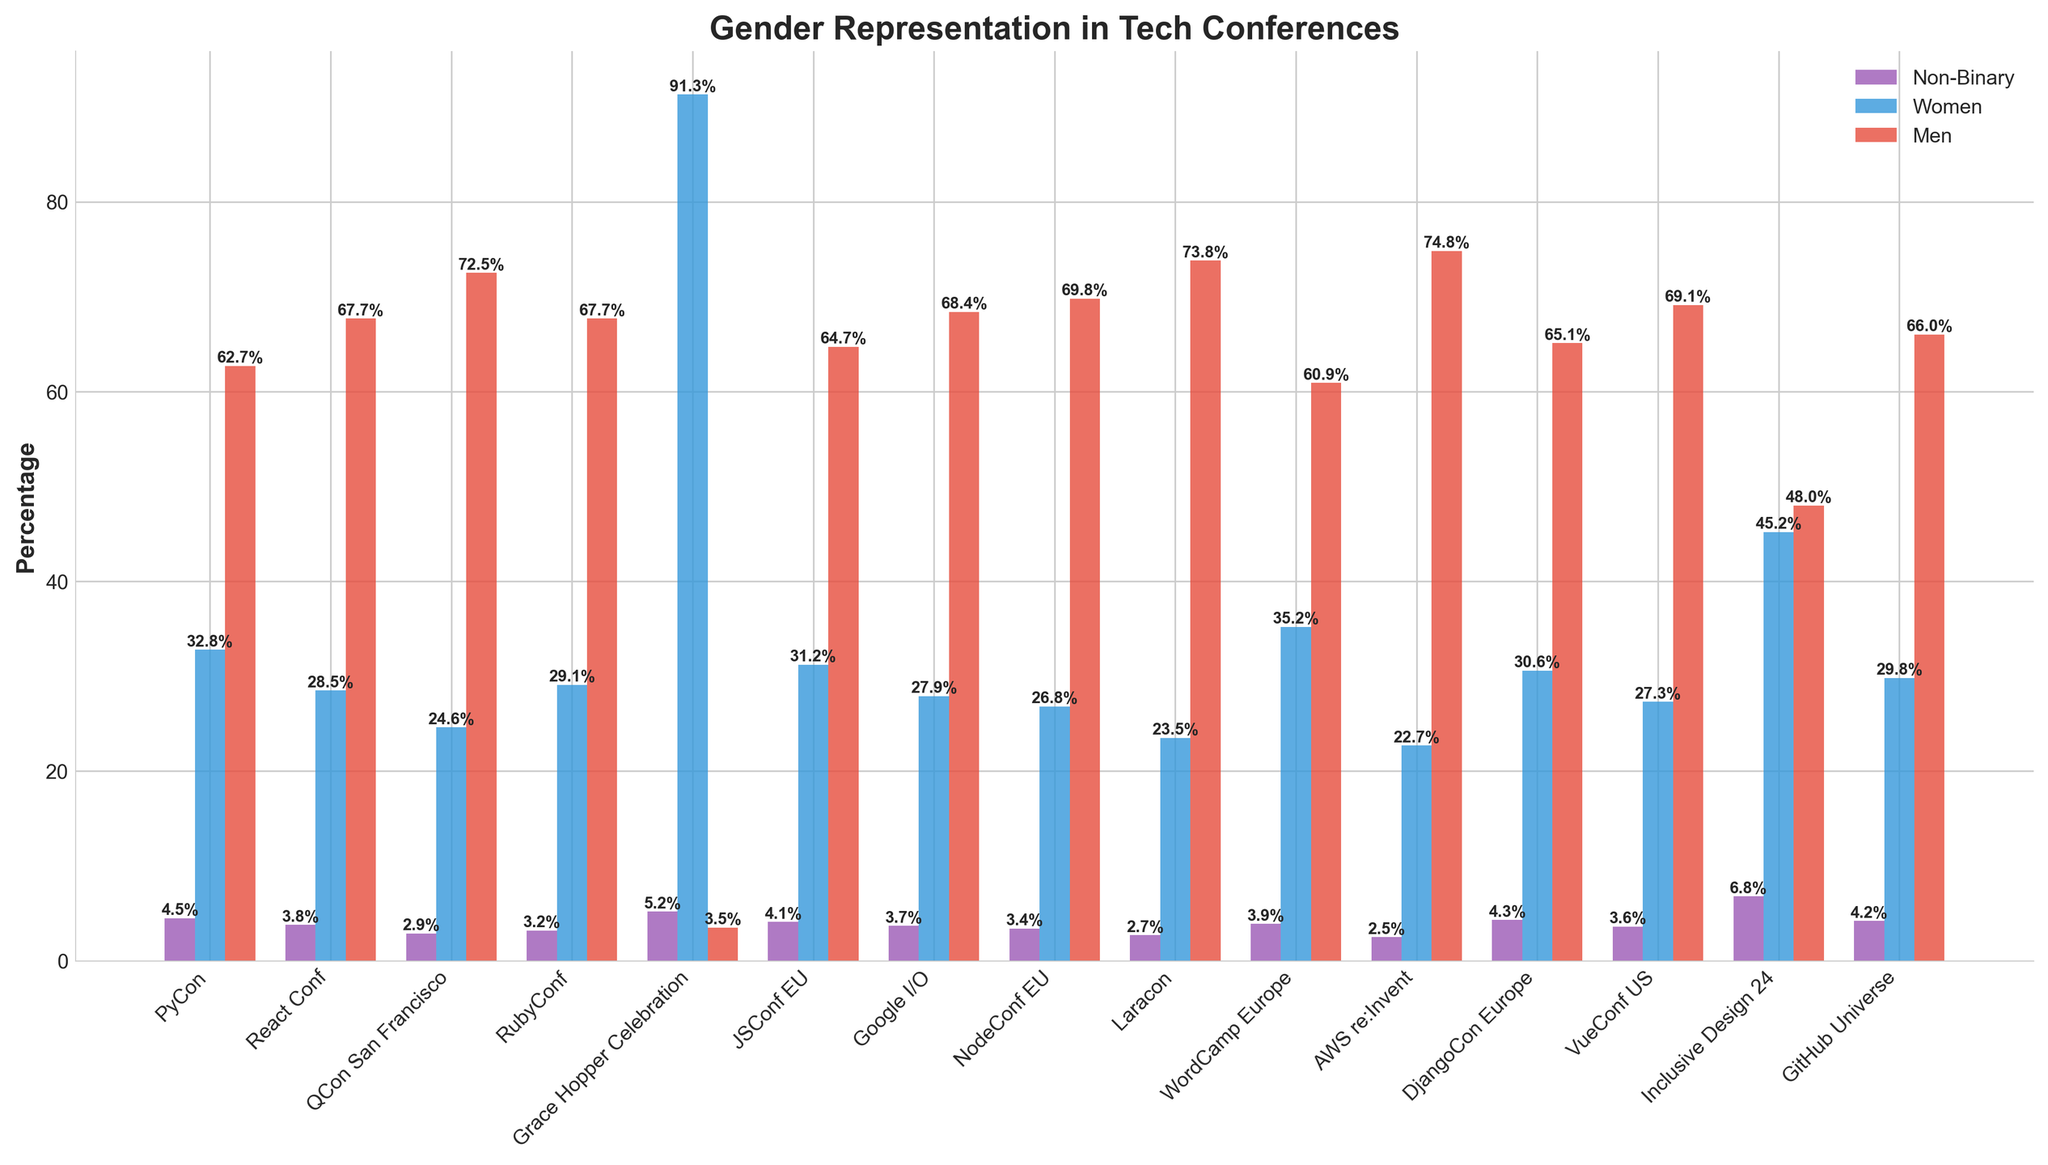Which event has the highest percentage of Non-Binary representation? Observing the chart, Grace Hopper Celebration has the tallest purple bar, which indicates the highest percentage of Non-Binary representation.
Answer: Grace Hopper Celebration What is the difference between the percentage of Women and Men at RubyConf? RubyConf has 29.1% Women and 67.7% Men. The difference is calculated as 67.7% - 29.1% = 38.6%.
Answer: 38.6% Which event has the smallest representation of Men? The red bar for Grace Hopper Celebration is the shortest among all the events, indicating the smallest percentage of Men.
Answer: Grace Hopper Celebration How does the percentage of Women at WordCamp Europe compare to that at Google I/O? The blue bar representing Women at WordCamp Europe is higher than the blue bar at Google I/O. The percentage of Women at WordCamp Europe is 35.2%, while at Google I/O, it is 27.9%.
Answer: Higher at WordCamp Europe What is the total percentage of Non-Binary and Women participants at PyCon? PyCon has 4.5% Non-Binary and 32.8% Women. Summing these percentages gives us 4.5% + 32.8% = 37.3%.
Answer: 37.3% Identify the event with the most balanced gender distribution. Observing the length of the bars, Inclusive Design 24 has the closest balance with 6.8% Non-Binary, 45.2% Women, and 48.0% Men. The bars are comparatively similar in height, indicating balance.
Answer: Inclusive Design 24 What is the average percentage of Men across all events? We sum the percentage values for Men across all events listed: 62.7, 67.7, 72.5, 67.7, 3.5, 64.7, 68.4, 69.8, 73.8, 60.9, 74.8, 65.1, 69.1, 48.0, 66.0. Summing these values: (62.7+67.7+72.5+67.7+3.5+64.7+68.4+69.8+73.8+60.9+74.8+65.1+69.1+48.0+66.0)=934.7. Dividing by the number of events (15): 934.7/15 = 62.31%.
Answer: 62.31% How does the representation of Non-Binary participants at DjangoCon Europe compare with JSConf EU? The purple bar for Non-Binary participants at DjangoCon Europe is slightly taller than that at JSConf EU, indicating a higher percentage. DjangoCon Europe has 4.3% Non-Binary participants compared to 4.1% for JSConf EU.
Answer: Higher at DjangoCon Europe What is the combined percentage of Women and Men at QCon San Francisco? QCon San Francisco has 24.6% Women and 72.5% Men. Summing these percentages gives us 24.6% + 72.5% = 97.1%.
Answer: 97.1% Which event has the highest percentage of Women representation, and what is that percentage? The tallest blue bar representing Women is at Grace Hopper Celebration, indicating the highest percentage of Women representation at 91.3%.
Answer: Grace Hopper Celebration, 91.3% Which two events have equal percentages of Men? From the chart, React Conf and RubyConf both have their red bars at the same height representing 67.7% Men.
Answer: React Conf and RubyConf 